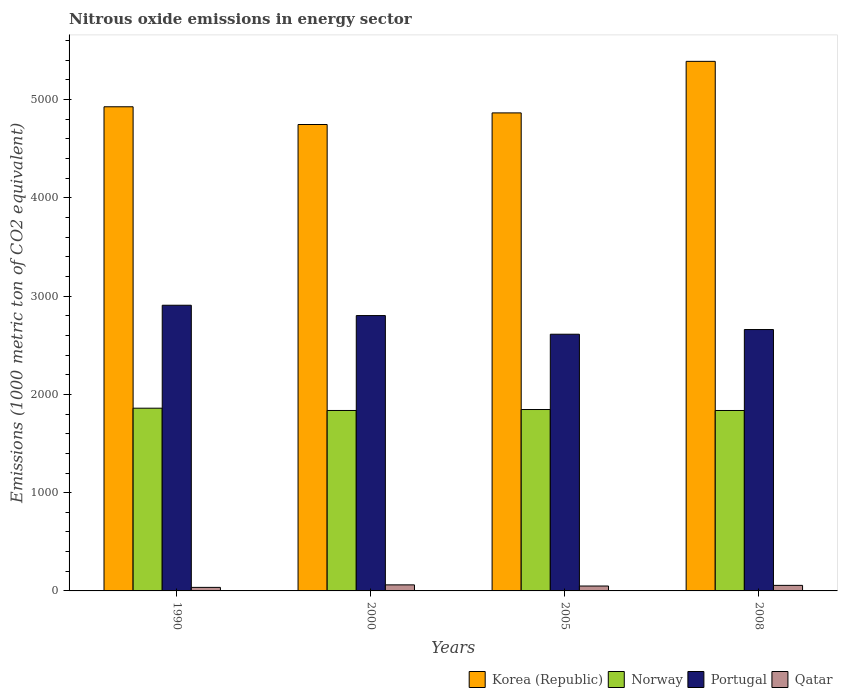How many different coloured bars are there?
Provide a short and direct response. 4. Are the number of bars on each tick of the X-axis equal?
Ensure brevity in your answer.  Yes. How many bars are there on the 3rd tick from the right?
Offer a terse response. 4. In how many cases, is the number of bars for a given year not equal to the number of legend labels?
Give a very brief answer. 0. What is the amount of nitrous oxide emitted in Korea (Republic) in 2008?
Make the answer very short. 5389.6. Across all years, what is the maximum amount of nitrous oxide emitted in Qatar?
Offer a very short reply. 61.6. Across all years, what is the minimum amount of nitrous oxide emitted in Portugal?
Your answer should be very brief. 2612.4. In which year was the amount of nitrous oxide emitted in Portugal maximum?
Give a very brief answer. 1990. What is the total amount of nitrous oxide emitted in Korea (Republic) in the graph?
Your answer should be compact. 1.99e+04. What is the difference between the amount of nitrous oxide emitted in Portugal in 1990 and that in 2008?
Your response must be concise. 247.3. What is the difference between the amount of nitrous oxide emitted in Qatar in 2005 and the amount of nitrous oxide emitted in Korea (Republic) in 1990?
Your answer should be compact. -4877.5. What is the average amount of nitrous oxide emitted in Portugal per year?
Offer a very short reply. 2745.62. In the year 1990, what is the difference between the amount of nitrous oxide emitted in Portugal and amount of nitrous oxide emitted in Norway?
Offer a very short reply. 1047.8. What is the ratio of the amount of nitrous oxide emitted in Portugal in 2000 to that in 2005?
Provide a short and direct response. 1.07. What is the difference between the highest and the second highest amount of nitrous oxide emitted in Korea (Republic)?
Keep it short and to the point. 462.2. What is the difference between the highest and the lowest amount of nitrous oxide emitted in Portugal?
Your response must be concise. 295.1. Is the sum of the amount of nitrous oxide emitted in Korea (Republic) in 1990 and 2000 greater than the maximum amount of nitrous oxide emitted in Norway across all years?
Give a very brief answer. Yes. What does the 4th bar from the left in 1990 represents?
Offer a terse response. Qatar. What does the 2nd bar from the right in 2005 represents?
Your response must be concise. Portugal. How many bars are there?
Offer a terse response. 16. Does the graph contain any zero values?
Your response must be concise. No. How many legend labels are there?
Keep it short and to the point. 4. How are the legend labels stacked?
Offer a very short reply. Horizontal. What is the title of the graph?
Give a very brief answer. Nitrous oxide emissions in energy sector. What is the label or title of the Y-axis?
Provide a succinct answer. Emissions (1000 metric ton of CO2 equivalent). What is the Emissions (1000 metric ton of CO2 equivalent) of Korea (Republic) in 1990?
Offer a terse response. 4927.4. What is the Emissions (1000 metric ton of CO2 equivalent) in Norway in 1990?
Offer a terse response. 1859.7. What is the Emissions (1000 metric ton of CO2 equivalent) of Portugal in 1990?
Offer a terse response. 2907.5. What is the Emissions (1000 metric ton of CO2 equivalent) in Qatar in 1990?
Provide a succinct answer. 36. What is the Emissions (1000 metric ton of CO2 equivalent) of Korea (Republic) in 2000?
Provide a succinct answer. 4746.8. What is the Emissions (1000 metric ton of CO2 equivalent) in Norway in 2000?
Your answer should be very brief. 1836.5. What is the Emissions (1000 metric ton of CO2 equivalent) of Portugal in 2000?
Your response must be concise. 2802.4. What is the Emissions (1000 metric ton of CO2 equivalent) of Qatar in 2000?
Your answer should be compact. 61.6. What is the Emissions (1000 metric ton of CO2 equivalent) of Korea (Republic) in 2005?
Offer a terse response. 4865. What is the Emissions (1000 metric ton of CO2 equivalent) in Norway in 2005?
Your answer should be compact. 1846.2. What is the Emissions (1000 metric ton of CO2 equivalent) of Portugal in 2005?
Your response must be concise. 2612.4. What is the Emissions (1000 metric ton of CO2 equivalent) of Qatar in 2005?
Your answer should be very brief. 49.9. What is the Emissions (1000 metric ton of CO2 equivalent) in Korea (Republic) in 2008?
Your answer should be compact. 5389.6. What is the Emissions (1000 metric ton of CO2 equivalent) in Norway in 2008?
Your answer should be compact. 1836.3. What is the Emissions (1000 metric ton of CO2 equivalent) of Portugal in 2008?
Provide a succinct answer. 2660.2. What is the Emissions (1000 metric ton of CO2 equivalent) in Qatar in 2008?
Make the answer very short. 56.6. Across all years, what is the maximum Emissions (1000 metric ton of CO2 equivalent) in Korea (Republic)?
Offer a terse response. 5389.6. Across all years, what is the maximum Emissions (1000 metric ton of CO2 equivalent) in Norway?
Your response must be concise. 1859.7. Across all years, what is the maximum Emissions (1000 metric ton of CO2 equivalent) in Portugal?
Offer a very short reply. 2907.5. Across all years, what is the maximum Emissions (1000 metric ton of CO2 equivalent) in Qatar?
Ensure brevity in your answer.  61.6. Across all years, what is the minimum Emissions (1000 metric ton of CO2 equivalent) in Korea (Republic)?
Offer a terse response. 4746.8. Across all years, what is the minimum Emissions (1000 metric ton of CO2 equivalent) of Norway?
Give a very brief answer. 1836.3. Across all years, what is the minimum Emissions (1000 metric ton of CO2 equivalent) of Portugal?
Offer a very short reply. 2612.4. Across all years, what is the minimum Emissions (1000 metric ton of CO2 equivalent) of Qatar?
Your response must be concise. 36. What is the total Emissions (1000 metric ton of CO2 equivalent) in Korea (Republic) in the graph?
Provide a short and direct response. 1.99e+04. What is the total Emissions (1000 metric ton of CO2 equivalent) in Norway in the graph?
Offer a very short reply. 7378.7. What is the total Emissions (1000 metric ton of CO2 equivalent) in Portugal in the graph?
Your answer should be compact. 1.10e+04. What is the total Emissions (1000 metric ton of CO2 equivalent) in Qatar in the graph?
Provide a succinct answer. 204.1. What is the difference between the Emissions (1000 metric ton of CO2 equivalent) of Korea (Republic) in 1990 and that in 2000?
Your response must be concise. 180.6. What is the difference between the Emissions (1000 metric ton of CO2 equivalent) of Norway in 1990 and that in 2000?
Your response must be concise. 23.2. What is the difference between the Emissions (1000 metric ton of CO2 equivalent) of Portugal in 1990 and that in 2000?
Keep it short and to the point. 105.1. What is the difference between the Emissions (1000 metric ton of CO2 equivalent) of Qatar in 1990 and that in 2000?
Make the answer very short. -25.6. What is the difference between the Emissions (1000 metric ton of CO2 equivalent) in Korea (Republic) in 1990 and that in 2005?
Make the answer very short. 62.4. What is the difference between the Emissions (1000 metric ton of CO2 equivalent) of Norway in 1990 and that in 2005?
Provide a short and direct response. 13.5. What is the difference between the Emissions (1000 metric ton of CO2 equivalent) in Portugal in 1990 and that in 2005?
Your answer should be very brief. 295.1. What is the difference between the Emissions (1000 metric ton of CO2 equivalent) of Korea (Republic) in 1990 and that in 2008?
Give a very brief answer. -462.2. What is the difference between the Emissions (1000 metric ton of CO2 equivalent) in Norway in 1990 and that in 2008?
Provide a succinct answer. 23.4. What is the difference between the Emissions (1000 metric ton of CO2 equivalent) in Portugal in 1990 and that in 2008?
Provide a succinct answer. 247.3. What is the difference between the Emissions (1000 metric ton of CO2 equivalent) of Qatar in 1990 and that in 2008?
Keep it short and to the point. -20.6. What is the difference between the Emissions (1000 metric ton of CO2 equivalent) of Korea (Republic) in 2000 and that in 2005?
Give a very brief answer. -118.2. What is the difference between the Emissions (1000 metric ton of CO2 equivalent) in Portugal in 2000 and that in 2005?
Give a very brief answer. 190. What is the difference between the Emissions (1000 metric ton of CO2 equivalent) of Korea (Republic) in 2000 and that in 2008?
Your response must be concise. -642.8. What is the difference between the Emissions (1000 metric ton of CO2 equivalent) of Portugal in 2000 and that in 2008?
Offer a terse response. 142.2. What is the difference between the Emissions (1000 metric ton of CO2 equivalent) of Korea (Republic) in 2005 and that in 2008?
Provide a short and direct response. -524.6. What is the difference between the Emissions (1000 metric ton of CO2 equivalent) of Portugal in 2005 and that in 2008?
Your response must be concise. -47.8. What is the difference between the Emissions (1000 metric ton of CO2 equivalent) in Korea (Republic) in 1990 and the Emissions (1000 metric ton of CO2 equivalent) in Norway in 2000?
Provide a short and direct response. 3090.9. What is the difference between the Emissions (1000 metric ton of CO2 equivalent) of Korea (Republic) in 1990 and the Emissions (1000 metric ton of CO2 equivalent) of Portugal in 2000?
Your answer should be very brief. 2125. What is the difference between the Emissions (1000 metric ton of CO2 equivalent) of Korea (Republic) in 1990 and the Emissions (1000 metric ton of CO2 equivalent) of Qatar in 2000?
Give a very brief answer. 4865.8. What is the difference between the Emissions (1000 metric ton of CO2 equivalent) in Norway in 1990 and the Emissions (1000 metric ton of CO2 equivalent) in Portugal in 2000?
Ensure brevity in your answer.  -942.7. What is the difference between the Emissions (1000 metric ton of CO2 equivalent) of Norway in 1990 and the Emissions (1000 metric ton of CO2 equivalent) of Qatar in 2000?
Ensure brevity in your answer.  1798.1. What is the difference between the Emissions (1000 metric ton of CO2 equivalent) of Portugal in 1990 and the Emissions (1000 metric ton of CO2 equivalent) of Qatar in 2000?
Give a very brief answer. 2845.9. What is the difference between the Emissions (1000 metric ton of CO2 equivalent) in Korea (Republic) in 1990 and the Emissions (1000 metric ton of CO2 equivalent) in Norway in 2005?
Keep it short and to the point. 3081.2. What is the difference between the Emissions (1000 metric ton of CO2 equivalent) of Korea (Republic) in 1990 and the Emissions (1000 metric ton of CO2 equivalent) of Portugal in 2005?
Make the answer very short. 2315. What is the difference between the Emissions (1000 metric ton of CO2 equivalent) of Korea (Republic) in 1990 and the Emissions (1000 metric ton of CO2 equivalent) of Qatar in 2005?
Your answer should be compact. 4877.5. What is the difference between the Emissions (1000 metric ton of CO2 equivalent) of Norway in 1990 and the Emissions (1000 metric ton of CO2 equivalent) of Portugal in 2005?
Make the answer very short. -752.7. What is the difference between the Emissions (1000 metric ton of CO2 equivalent) of Norway in 1990 and the Emissions (1000 metric ton of CO2 equivalent) of Qatar in 2005?
Provide a short and direct response. 1809.8. What is the difference between the Emissions (1000 metric ton of CO2 equivalent) of Portugal in 1990 and the Emissions (1000 metric ton of CO2 equivalent) of Qatar in 2005?
Your response must be concise. 2857.6. What is the difference between the Emissions (1000 metric ton of CO2 equivalent) in Korea (Republic) in 1990 and the Emissions (1000 metric ton of CO2 equivalent) in Norway in 2008?
Offer a very short reply. 3091.1. What is the difference between the Emissions (1000 metric ton of CO2 equivalent) in Korea (Republic) in 1990 and the Emissions (1000 metric ton of CO2 equivalent) in Portugal in 2008?
Make the answer very short. 2267.2. What is the difference between the Emissions (1000 metric ton of CO2 equivalent) in Korea (Republic) in 1990 and the Emissions (1000 metric ton of CO2 equivalent) in Qatar in 2008?
Your answer should be very brief. 4870.8. What is the difference between the Emissions (1000 metric ton of CO2 equivalent) in Norway in 1990 and the Emissions (1000 metric ton of CO2 equivalent) in Portugal in 2008?
Offer a very short reply. -800.5. What is the difference between the Emissions (1000 metric ton of CO2 equivalent) of Norway in 1990 and the Emissions (1000 metric ton of CO2 equivalent) of Qatar in 2008?
Offer a very short reply. 1803.1. What is the difference between the Emissions (1000 metric ton of CO2 equivalent) in Portugal in 1990 and the Emissions (1000 metric ton of CO2 equivalent) in Qatar in 2008?
Offer a very short reply. 2850.9. What is the difference between the Emissions (1000 metric ton of CO2 equivalent) in Korea (Republic) in 2000 and the Emissions (1000 metric ton of CO2 equivalent) in Norway in 2005?
Offer a very short reply. 2900.6. What is the difference between the Emissions (1000 metric ton of CO2 equivalent) in Korea (Republic) in 2000 and the Emissions (1000 metric ton of CO2 equivalent) in Portugal in 2005?
Provide a short and direct response. 2134.4. What is the difference between the Emissions (1000 metric ton of CO2 equivalent) in Korea (Republic) in 2000 and the Emissions (1000 metric ton of CO2 equivalent) in Qatar in 2005?
Give a very brief answer. 4696.9. What is the difference between the Emissions (1000 metric ton of CO2 equivalent) of Norway in 2000 and the Emissions (1000 metric ton of CO2 equivalent) of Portugal in 2005?
Offer a terse response. -775.9. What is the difference between the Emissions (1000 metric ton of CO2 equivalent) in Norway in 2000 and the Emissions (1000 metric ton of CO2 equivalent) in Qatar in 2005?
Make the answer very short. 1786.6. What is the difference between the Emissions (1000 metric ton of CO2 equivalent) of Portugal in 2000 and the Emissions (1000 metric ton of CO2 equivalent) of Qatar in 2005?
Ensure brevity in your answer.  2752.5. What is the difference between the Emissions (1000 metric ton of CO2 equivalent) of Korea (Republic) in 2000 and the Emissions (1000 metric ton of CO2 equivalent) of Norway in 2008?
Provide a short and direct response. 2910.5. What is the difference between the Emissions (1000 metric ton of CO2 equivalent) of Korea (Republic) in 2000 and the Emissions (1000 metric ton of CO2 equivalent) of Portugal in 2008?
Keep it short and to the point. 2086.6. What is the difference between the Emissions (1000 metric ton of CO2 equivalent) of Korea (Republic) in 2000 and the Emissions (1000 metric ton of CO2 equivalent) of Qatar in 2008?
Ensure brevity in your answer.  4690.2. What is the difference between the Emissions (1000 metric ton of CO2 equivalent) in Norway in 2000 and the Emissions (1000 metric ton of CO2 equivalent) in Portugal in 2008?
Your response must be concise. -823.7. What is the difference between the Emissions (1000 metric ton of CO2 equivalent) of Norway in 2000 and the Emissions (1000 metric ton of CO2 equivalent) of Qatar in 2008?
Keep it short and to the point. 1779.9. What is the difference between the Emissions (1000 metric ton of CO2 equivalent) in Portugal in 2000 and the Emissions (1000 metric ton of CO2 equivalent) in Qatar in 2008?
Ensure brevity in your answer.  2745.8. What is the difference between the Emissions (1000 metric ton of CO2 equivalent) in Korea (Republic) in 2005 and the Emissions (1000 metric ton of CO2 equivalent) in Norway in 2008?
Ensure brevity in your answer.  3028.7. What is the difference between the Emissions (1000 metric ton of CO2 equivalent) of Korea (Republic) in 2005 and the Emissions (1000 metric ton of CO2 equivalent) of Portugal in 2008?
Give a very brief answer. 2204.8. What is the difference between the Emissions (1000 metric ton of CO2 equivalent) in Korea (Republic) in 2005 and the Emissions (1000 metric ton of CO2 equivalent) in Qatar in 2008?
Give a very brief answer. 4808.4. What is the difference between the Emissions (1000 metric ton of CO2 equivalent) of Norway in 2005 and the Emissions (1000 metric ton of CO2 equivalent) of Portugal in 2008?
Offer a terse response. -814. What is the difference between the Emissions (1000 metric ton of CO2 equivalent) in Norway in 2005 and the Emissions (1000 metric ton of CO2 equivalent) in Qatar in 2008?
Offer a very short reply. 1789.6. What is the difference between the Emissions (1000 metric ton of CO2 equivalent) of Portugal in 2005 and the Emissions (1000 metric ton of CO2 equivalent) of Qatar in 2008?
Give a very brief answer. 2555.8. What is the average Emissions (1000 metric ton of CO2 equivalent) in Korea (Republic) per year?
Keep it short and to the point. 4982.2. What is the average Emissions (1000 metric ton of CO2 equivalent) in Norway per year?
Offer a terse response. 1844.67. What is the average Emissions (1000 metric ton of CO2 equivalent) in Portugal per year?
Provide a succinct answer. 2745.62. What is the average Emissions (1000 metric ton of CO2 equivalent) of Qatar per year?
Keep it short and to the point. 51.02. In the year 1990, what is the difference between the Emissions (1000 metric ton of CO2 equivalent) in Korea (Republic) and Emissions (1000 metric ton of CO2 equivalent) in Norway?
Ensure brevity in your answer.  3067.7. In the year 1990, what is the difference between the Emissions (1000 metric ton of CO2 equivalent) in Korea (Republic) and Emissions (1000 metric ton of CO2 equivalent) in Portugal?
Provide a short and direct response. 2019.9. In the year 1990, what is the difference between the Emissions (1000 metric ton of CO2 equivalent) in Korea (Republic) and Emissions (1000 metric ton of CO2 equivalent) in Qatar?
Your answer should be very brief. 4891.4. In the year 1990, what is the difference between the Emissions (1000 metric ton of CO2 equivalent) of Norway and Emissions (1000 metric ton of CO2 equivalent) of Portugal?
Keep it short and to the point. -1047.8. In the year 1990, what is the difference between the Emissions (1000 metric ton of CO2 equivalent) in Norway and Emissions (1000 metric ton of CO2 equivalent) in Qatar?
Provide a succinct answer. 1823.7. In the year 1990, what is the difference between the Emissions (1000 metric ton of CO2 equivalent) of Portugal and Emissions (1000 metric ton of CO2 equivalent) of Qatar?
Your answer should be very brief. 2871.5. In the year 2000, what is the difference between the Emissions (1000 metric ton of CO2 equivalent) in Korea (Republic) and Emissions (1000 metric ton of CO2 equivalent) in Norway?
Provide a short and direct response. 2910.3. In the year 2000, what is the difference between the Emissions (1000 metric ton of CO2 equivalent) of Korea (Republic) and Emissions (1000 metric ton of CO2 equivalent) of Portugal?
Your answer should be very brief. 1944.4. In the year 2000, what is the difference between the Emissions (1000 metric ton of CO2 equivalent) in Korea (Republic) and Emissions (1000 metric ton of CO2 equivalent) in Qatar?
Your response must be concise. 4685.2. In the year 2000, what is the difference between the Emissions (1000 metric ton of CO2 equivalent) of Norway and Emissions (1000 metric ton of CO2 equivalent) of Portugal?
Offer a very short reply. -965.9. In the year 2000, what is the difference between the Emissions (1000 metric ton of CO2 equivalent) of Norway and Emissions (1000 metric ton of CO2 equivalent) of Qatar?
Your answer should be very brief. 1774.9. In the year 2000, what is the difference between the Emissions (1000 metric ton of CO2 equivalent) of Portugal and Emissions (1000 metric ton of CO2 equivalent) of Qatar?
Provide a short and direct response. 2740.8. In the year 2005, what is the difference between the Emissions (1000 metric ton of CO2 equivalent) in Korea (Republic) and Emissions (1000 metric ton of CO2 equivalent) in Norway?
Offer a very short reply. 3018.8. In the year 2005, what is the difference between the Emissions (1000 metric ton of CO2 equivalent) of Korea (Republic) and Emissions (1000 metric ton of CO2 equivalent) of Portugal?
Ensure brevity in your answer.  2252.6. In the year 2005, what is the difference between the Emissions (1000 metric ton of CO2 equivalent) of Korea (Republic) and Emissions (1000 metric ton of CO2 equivalent) of Qatar?
Offer a terse response. 4815.1. In the year 2005, what is the difference between the Emissions (1000 metric ton of CO2 equivalent) of Norway and Emissions (1000 metric ton of CO2 equivalent) of Portugal?
Your answer should be compact. -766.2. In the year 2005, what is the difference between the Emissions (1000 metric ton of CO2 equivalent) in Norway and Emissions (1000 metric ton of CO2 equivalent) in Qatar?
Offer a very short reply. 1796.3. In the year 2005, what is the difference between the Emissions (1000 metric ton of CO2 equivalent) of Portugal and Emissions (1000 metric ton of CO2 equivalent) of Qatar?
Offer a very short reply. 2562.5. In the year 2008, what is the difference between the Emissions (1000 metric ton of CO2 equivalent) of Korea (Republic) and Emissions (1000 metric ton of CO2 equivalent) of Norway?
Offer a very short reply. 3553.3. In the year 2008, what is the difference between the Emissions (1000 metric ton of CO2 equivalent) in Korea (Republic) and Emissions (1000 metric ton of CO2 equivalent) in Portugal?
Your answer should be very brief. 2729.4. In the year 2008, what is the difference between the Emissions (1000 metric ton of CO2 equivalent) in Korea (Republic) and Emissions (1000 metric ton of CO2 equivalent) in Qatar?
Your answer should be very brief. 5333. In the year 2008, what is the difference between the Emissions (1000 metric ton of CO2 equivalent) in Norway and Emissions (1000 metric ton of CO2 equivalent) in Portugal?
Ensure brevity in your answer.  -823.9. In the year 2008, what is the difference between the Emissions (1000 metric ton of CO2 equivalent) in Norway and Emissions (1000 metric ton of CO2 equivalent) in Qatar?
Provide a short and direct response. 1779.7. In the year 2008, what is the difference between the Emissions (1000 metric ton of CO2 equivalent) of Portugal and Emissions (1000 metric ton of CO2 equivalent) of Qatar?
Offer a terse response. 2603.6. What is the ratio of the Emissions (1000 metric ton of CO2 equivalent) of Korea (Republic) in 1990 to that in 2000?
Keep it short and to the point. 1.04. What is the ratio of the Emissions (1000 metric ton of CO2 equivalent) in Norway in 1990 to that in 2000?
Ensure brevity in your answer.  1.01. What is the ratio of the Emissions (1000 metric ton of CO2 equivalent) in Portugal in 1990 to that in 2000?
Provide a succinct answer. 1.04. What is the ratio of the Emissions (1000 metric ton of CO2 equivalent) in Qatar in 1990 to that in 2000?
Give a very brief answer. 0.58. What is the ratio of the Emissions (1000 metric ton of CO2 equivalent) of Korea (Republic) in 1990 to that in 2005?
Your answer should be very brief. 1.01. What is the ratio of the Emissions (1000 metric ton of CO2 equivalent) in Norway in 1990 to that in 2005?
Offer a very short reply. 1.01. What is the ratio of the Emissions (1000 metric ton of CO2 equivalent) in Portugal in 1990 to that in 2005?
Provide a short and direct response. 1.11. What is the ratio of the Emissions (1000 metric ton of CO2 equivalent) in Qatar in 1990 to that in 2005?
Provide a short and direct response. 0.72. What is the ratio of the Emissions (1000 metric ton of CO2 equivalent) in Korea (Republic) in 1990 to that in 2008?
Your answer should be very brief. 0.91. What is the ratio of the Emissions (1000 metric ton of CO2 equivalent) in Norway in 1990 to that in 2008?
Keep it short and to the point. 1.01. What is the ratio of the Emissions (1000 metric ton of CO2 equivalent) in Portugal in 1990 to that in 2008?
Make the answer very short. 1.09. What is the ratio of the Emissions (1000 metric ton of CO2 equivalent) in Qatar in 1990 to that in 2008?
Your response must be concise. 0.64. What is the ratio of the Emissions (1000 metric ton of CO2 equivalent) in Korea (Republic) in 2000 to that in 2005?
Your response must be concise. 0.98. What is the ratio of the Emissions (1000 metric ton of CO2 equivalent) in Portugal in 2000 to that in 2005?
Offer a terse response. 1.07. What is the ratio of the Emissions (1000 metric ton of CO2 equivalent) of Qatar in 2000 to that in 2005?
Your answer should be compact. 1.23. What is the ratio of the Emissions (1000 metric ton of CO2 equivalent) in Korea (Republic) in 2000 to that in 2008?
Your answer should be very brief. 0.88. What is the ratio of the Emissions (1000 metric ton of CO2 equivalent) of Portugal in 2000 to that in 2008?
Your answer should be compact. 1.05. What is the ratio of the Emissions (1000 metric ton of CO2 equivalent) in Qatar in 2000 to that in 2008?
Offer a very short reply. 1.09. What is the ratio of the Emissions (1000 metric ton of CO2 equivalent) in Korea (Republic) in 2005 to that in 2008?
Offer a terse response. 0.9. What is the ratio of the Emissions (1000 metric ton of CO2 equivalent) in Norway in 2005 to that in 2008?
Your answer should be compact. 1.01. What is the ratio of the Emissions (1000 metric ton of CO2 equivalent) of Qatar in 2005 to that in 2008?
Keep it short and to the point. 0.88. What is the difference between the highest and the second highest Emissions (1000 metric ton of CO2 equivalent) of Korea (Republic)?
Your answer should be very brief. 462.2. What is the difference between the highest and the second highest Emissions (1000 metric ton of CO2 equivalent) of Portugal?
Your answer should be very brief. 105.1. What is the difference between the highest and the second highest Emissions (1000 metric ton of CO2 equivalent) in Qatar?
Offer a terse response. 5. What is the difference between the highest and the lowest Emissions (1000 metric ton of CO2 equivalent) of Korea (Republic)?
Provide a short and direct response. 642.8. What is the difference between the highest and the lowest Emissions (1000 metric ton of CO2 equivalent) of Norway?
Your answer should be compact. 23.4. What is the difference between the highest and the lowest Emissions (1000 metric ton of CO2 equivalent) in Portugal?
Offer a terse response. 295.1. What is the difference between the highest and the lowest Emissions (1000 metric ton of CO2 equivalent) in Qatar?
Ensure brevity in your answer.  25.6. 